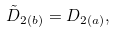Convert formula to latex. <formula><loc_0><loc_0><loc_500><loc_500>\tilde { D } _ { 2 ( b ) } = D _ { 2 ( a ) } ,</formula> 